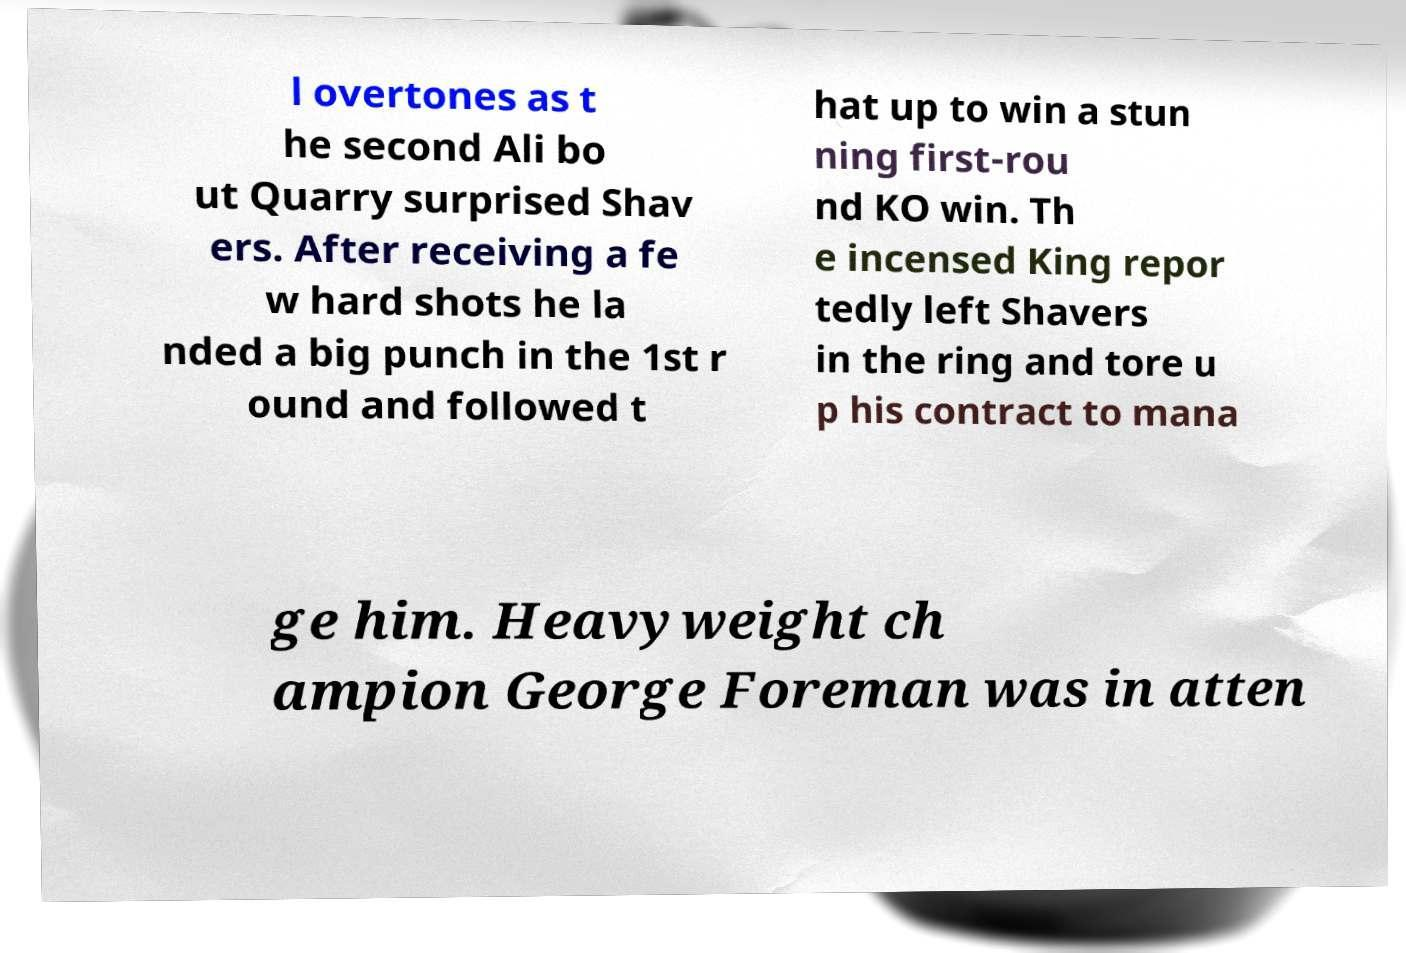Could you assist in decoding the text presented in this image and type it out clearly? l overtones as t he second Ali bo ut Quarry surprised Shav ers. After receiving a fe w hard shots he la nded a big punch in the 1st r ound and followed t hat up to win a stun ning first-rou nd KO win. Th e incensed King repor tedly left Shavers in the ring and tore u p his contract to mana ge him. Heavyweight ch ampion George Foreman was in atten 